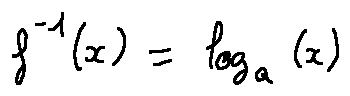Convert formula to latex. <formula><loc_0><loc_0><loc_500><loc_500>f ^ { - 1 } ( x ) = \log _ { a } ( x )</formula> 